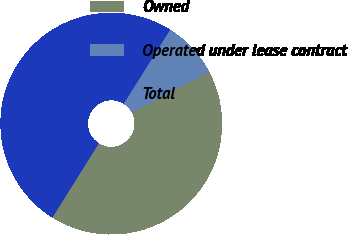<chart> <loc_0><loc_0><loc_500><loc_500><pie_chart><fcel>Owned<fcel>Operated under lease contract<fcel>Total<nl><fcel>41.68%<fcel>8.32%<fcel>50.0%<nl></chart> 